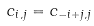Convert formula to latex. <formula><loc_0><loc_0><loc_500><loc_500>c _ { i , j } = c _ { - i + j , j }</formula> 